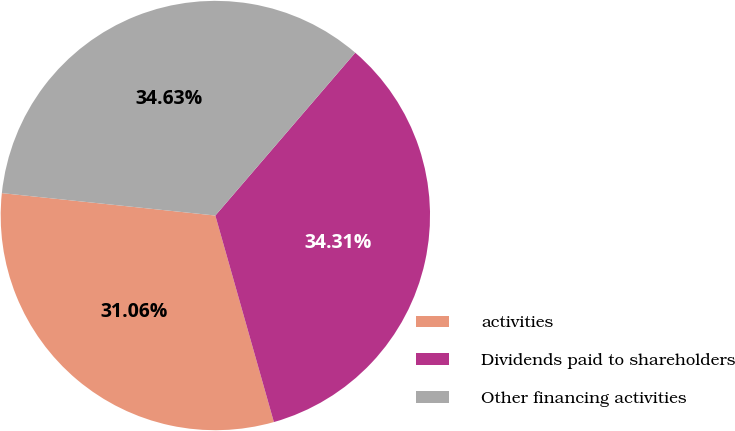Convert chart. <chart><loc_0><loc_0><loc_500><loc_500><pie_chart><fcel>activities<fcel>Dividends paid to shareholders<fcel>Other financing activities<nl><fcel>31.06%<fcel>34.31%<fcel>34.63%<nl></chart> 